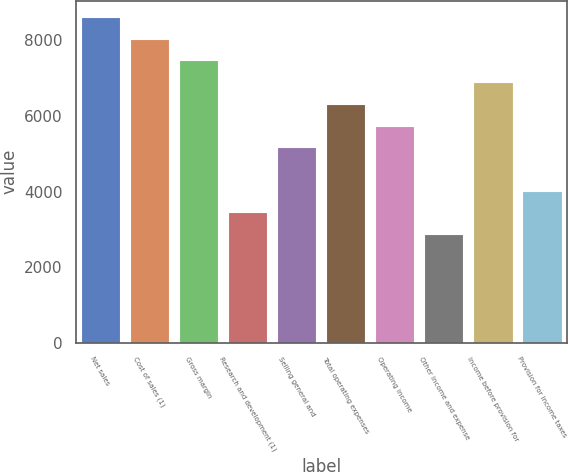Convert chart. <chart><loc_0><loc_0><loc_500><loc_500><bar_chart><fcel>Net sales<fcel>Cost of sales (1)<fcel>Gross margin<fcel>Research and development (1)<fcel>Selling general and<fcel>Total operating expenses<fcel>Operating income<fcel>Other income and expense<fcel>Income before provision for<fcel>Provision for income taxes<nl><fcel>8623.15<fcel>8048.31<fcel>7473.48<fcel>3449.66<fcel>5174.15<fcel>6323.81<fcel>5748.98<fcel>2874.82<fcel>6898.65<fcel>4024.49<nl></chart> 